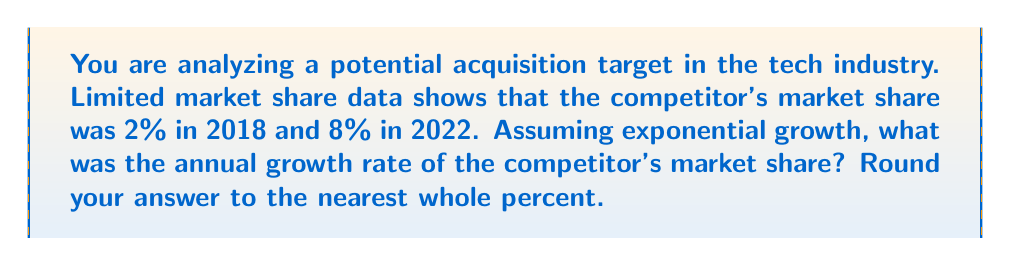Give your solution to this math problem. To solve this inverse problem and reconstruct the growth trajectory, we'll use the exponential growth formula:

$$ A = P(1 + r)^t $$

Where:
$A$ = Final amount (8% market share)
$P$ = Initial amount (2% market share)
$r$ = Annual growth rate (unknown)
$t$ = Time period (4 years, from 2018 to 2022)

Step 1: Plug in the known values
$$ 8 = 2(1 + r)^4 $$

Step 2: Divide both sides by 2
$$ 4 = (1 + r)^4 $$

Step 3: Take the fourth root of both sides
$$ \sqrt[4]{4} = 1 + r $$

Step 4: Solve for r
$$ r = \sqrt[4]{4} - 1 $$

Step 5: Calculate the value
$$ r \approx 1.4142 - 1 = 0.4142 $$

Step 6: Convert to percentage and round to the nearest whole percent
$$ 0.4142 * 100 \approx 41\% $$
Answer: 41% 